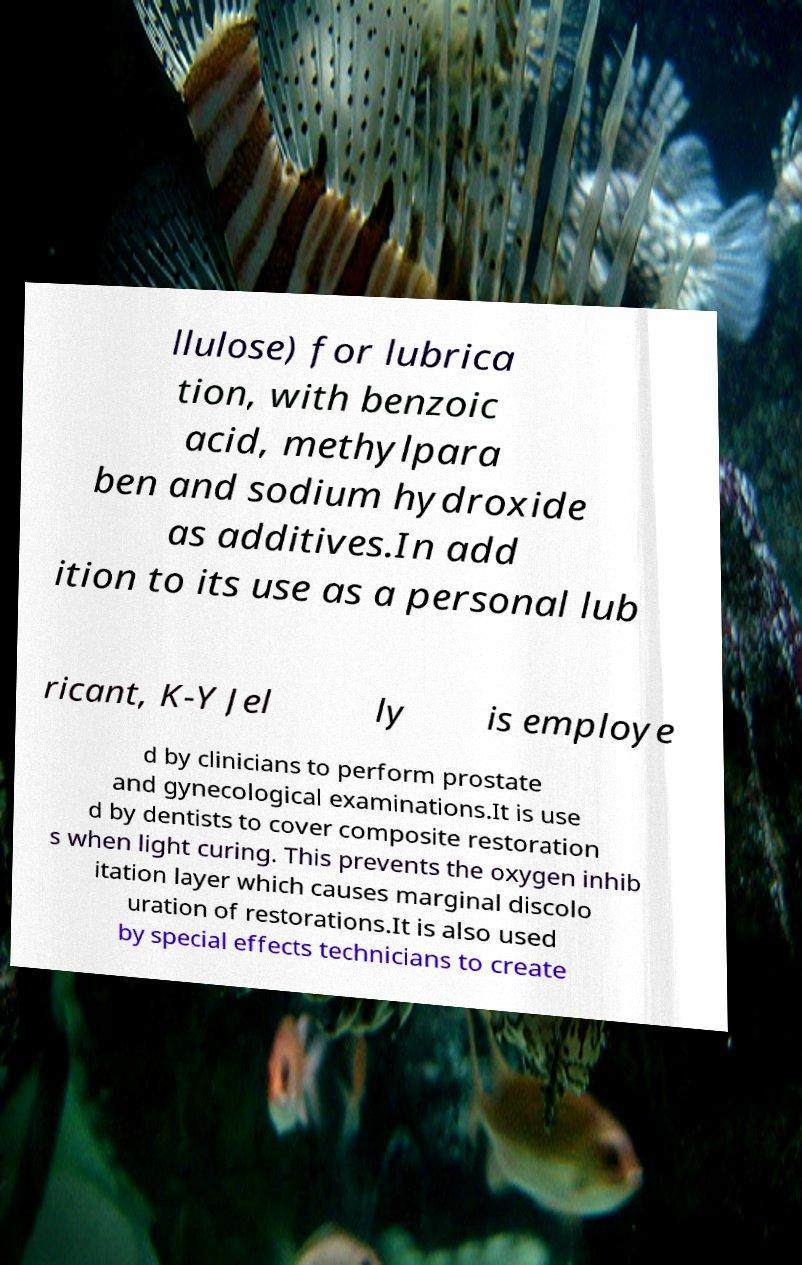Could you extract and type out the text from this image? llulose) for lubrica tion, with benzoic acid, methylpara ben and sodium hydroxide as additives.In add ition to its use as a personal lub ricant, K-Y Jel ly is employe d by clinicians to perform prostate and gynecological examinations.It is use d by dentists to cover composite restoration s when light curing. This prevents the oxygen inhib itation layer which causes marginal discolo uration of restorations.It is also used by special effects technicians to create 